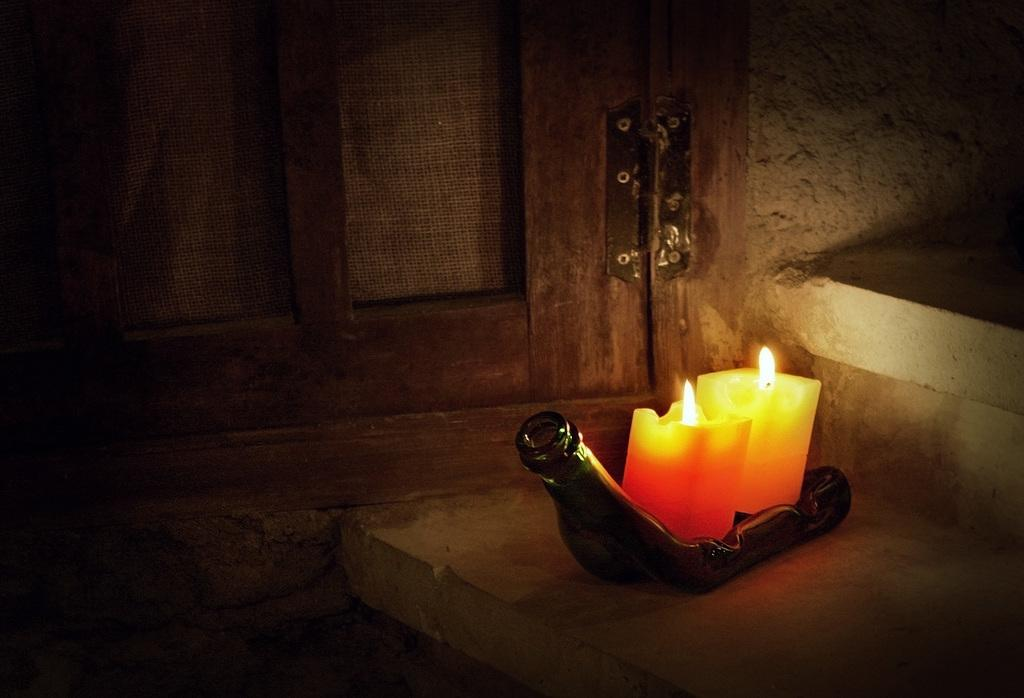What objects are present in the image that emit light? There are lighted candles in the image. What is the candles' position relative to another object? The candles are above a bottle. What can be seen in the background of the image? There is a window and a wall in the background of the image. What type of rake is being used by the police in the class depicted in the image? There is no class, police, or rake present in the image. 